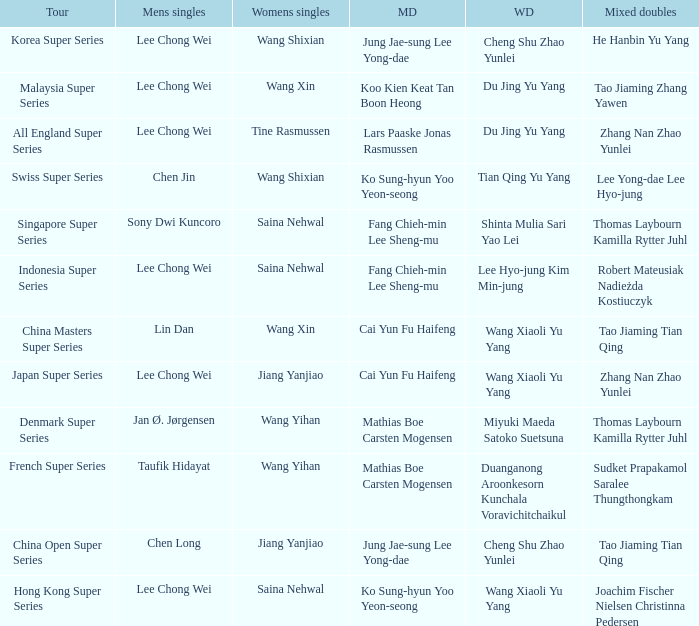Who is the womens doubles on the tour french super series? Duanganong Aroonkesorn Kunchala Voravichitchaikul. I'm looking to parse the entire table for insights. Could you assist me with that? {'header': ['Tour', 'Mens singles', 'Womens singles', 'MD', 'WD', 'Mixed doubles'], 'rows': [['Korea Super Series', 'Lee Chong Wei', 'Wang Shixian', 'Jung Jae-sung Lee Yong-dae', 'Cheng Shu Zhao Yunlei', 'He Hanbin Yu Yang'], ['Malaysia Super Series', 'Lee Chong Wei', 'Wang Xin', 'Koo Kien Keat Tan Boon Heong', 'Du Jing Yu Yang', 'Tao Jiaming Zhang Yawen'], ['All England Super Series', 'Lee Chong Wei', 'Tine Rasmussen', 'Lars Paaske Jonas Rasmussen', 'Du Jing Yu Yang', 'Zhang Nan Zhao Yunlei'], ['Swiss Super Series', 'Chen Jin', 'Wang Shixian', 'Ko Sung-hyun Yoo Yeon-seong', 'Tian Qing Yu Yang', 'Lee Yong-dae Lee Hyo-jung'], ['Singapore Super Series', 'Sony Dwi Kuncoro', 'Saina Nehwal', 'Fang Chieh-min Lee Sheng-mu', 'Shinta Mulia Sari Yao Lei', 'Thomas Laybourn Kamilla Rytter Juhl'], ['Indonesia Super Series', 'Lee Chong Wei', 'Saina Nehwal', 'Fang Chieh-min Lee Sheng-mu', 'Lee Hyo-jung Kim Min-jung', 'Robert Mateusiak Nadieżda Kostiuczyk'], ['China Masters Super Series', 'Lin Dan', 'Wang Xin', 'Cai Yun Fu Haifeng', 'Wang Xiaoli Yu Yang', 'Tao Jiaming Tian Qing'], ['Japan Super Series', 'Lee Chong Wei', 'Jiang Yanjiao', 'Cai Yun Fu Haifeng', 'Wang Xiaoli Yu Yang', 'Zhang Nan Zhao Yunlei'], ['Denmark Super Series', 'Jan Ø. Jørgensen', 'Wang Yihan', 'Mathias Boe Carsten Mogensen', 'Miyuki Maeda Satoko Suetsuna', 'Thomas Laybourn Kamilla Rytter Juhl'], ['French Super Series', 'Taufik Hidayat', 'Wang Yihan', 'Mathias Boe Carsten Mogensen', 'Duanganong Aroonkesorn Kunchala Voravichitchaikul', 'Sudket Prapakamol Saralee Thungthongkam'], ['China Open Super Series', 'Chen Long', 'Jiang Yanjiao', 'Jung Jae-sung Lee Yong-dae', 'Cheng Shu Zhao Yunlei', 'Tao Jiaming Tian Qing'], ['Hong Kong Super Series', 'Lee Chong Wei', 'Saina Nehwal', 'Ko Sung-hyun Yoo Yeon-seong', 'Wang Xiaoli Yu Yang', 'Joachim Fischer Nielsen Christinna Pedersen']]} 